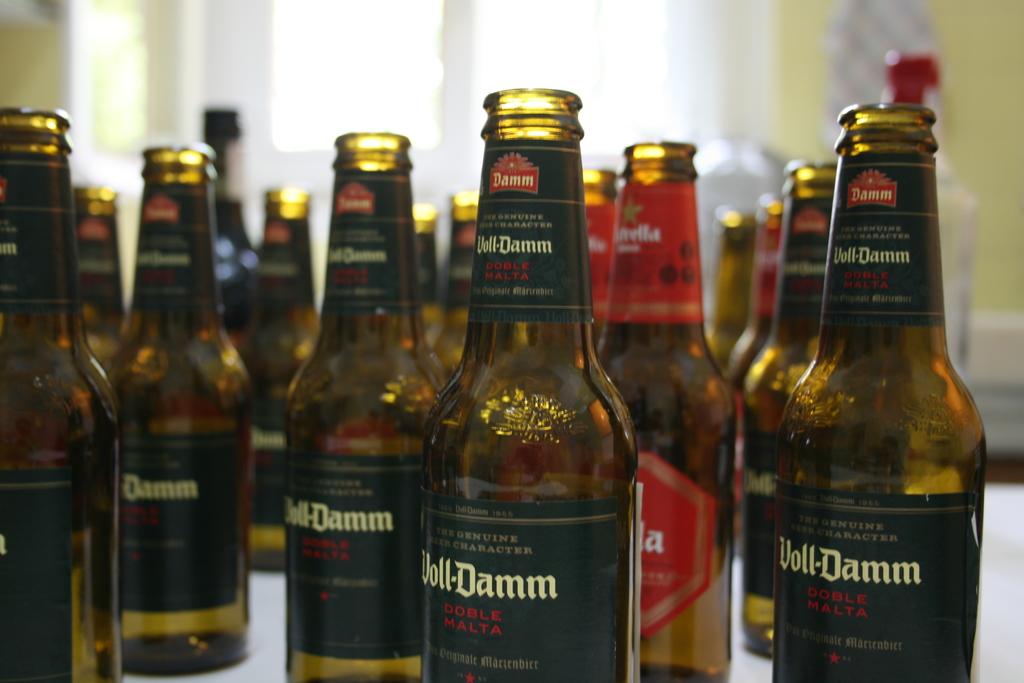What drinks are these?
Offer a very short reply. Voll-damm. 